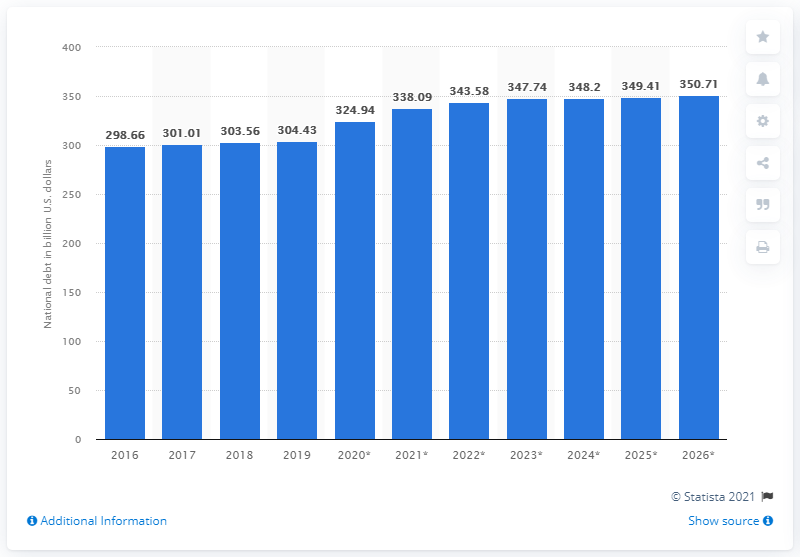Outline some significant characteristics in this image. In 2019, Portugal's national debt was approximately 304.43 billion dollars. 